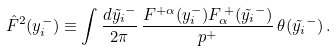<formula> <loc_0><loc_0><loc_500><loc_500>\hat { F } ^ { 2 } ( y _ { i } ^ { - } ) \equiv \int \frac { d \tilde { y _ { i } } ^ { - } } { 2 \pi } \, \frac { F ^ { + \alpha } ( y _ { i } ^ { - } ) F _ { \alpha } ^ { \, + } ( \tilde { y _ { i } } ^ { - } ) } { p ^ { + } } \, \theta ( \tilde { y _ { i } } ^ { - } ) \, .</formula> 